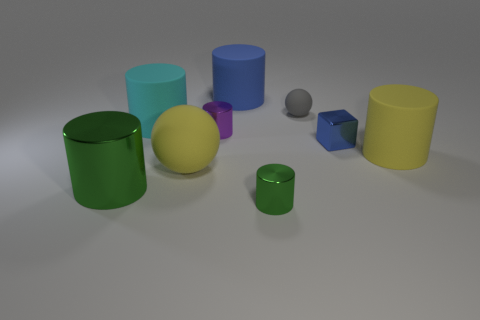Subtract all yellow matte cylinders. How many cylinders are left? 5 Subtract 1 cubes. How many cubes are left? 0 Subtract all purple cylinders. How many cylinders are left? 5 Subtract all green spheres. How many green cylinders are left? 2 Add 1 big yellow rubber balls. How many objects exist? 10 Subtract all cylinders. How many objects are left? 3 Add 5 yellow rubber spheres. How many yellow rubber spheres exist? 6 Subtract 1 purple cylinders. How many objects are left? 8 Subtract all gray balls. Subtract all yellow blocks. How many balls are left? 1 Subtract all big yellow metal things. Subtract all small green metallic cylinders. How many objects are left? 8 